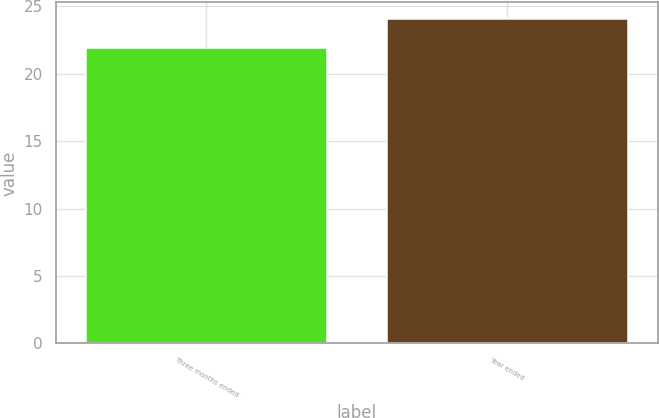Convert chart to OTSL. <chart><loc_0><loc_0><loc_500><loc_500><bar_chart><fcel>Three months ended<fcel>Year ended<nl><fcel>21.9<fcel>24.1<nl></chart> 